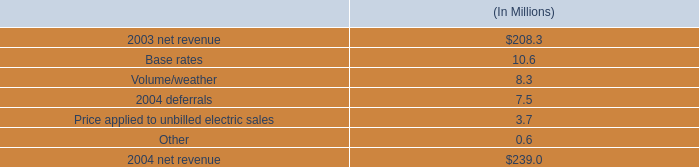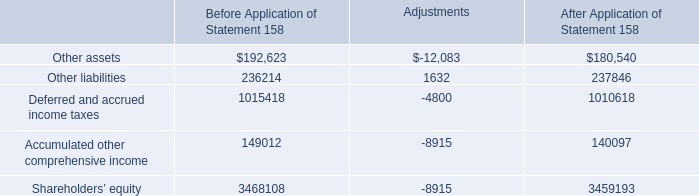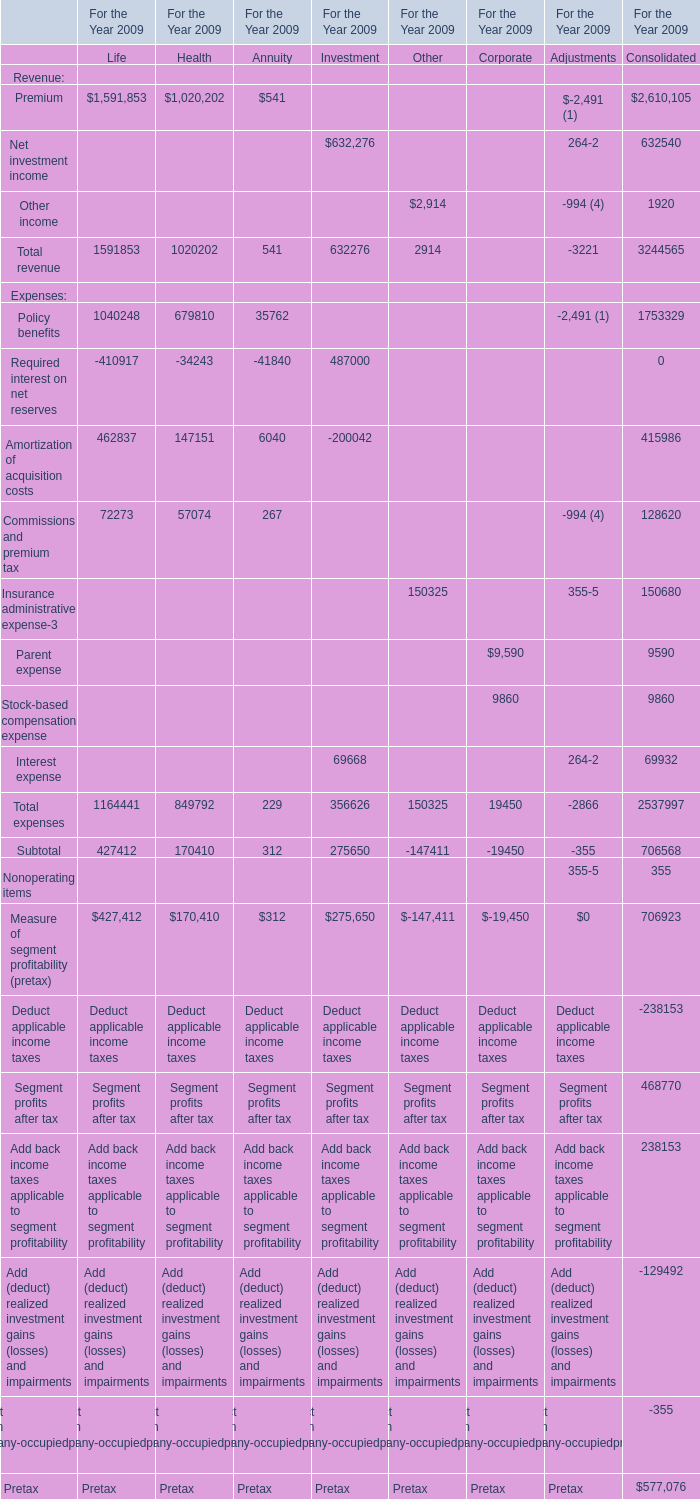what is the growth rate in net revenue for entergy new orleans , inc . in 2004? 
Computations: ((239.0 - 208.3) / 208.3)
Answer: 0.14738. 